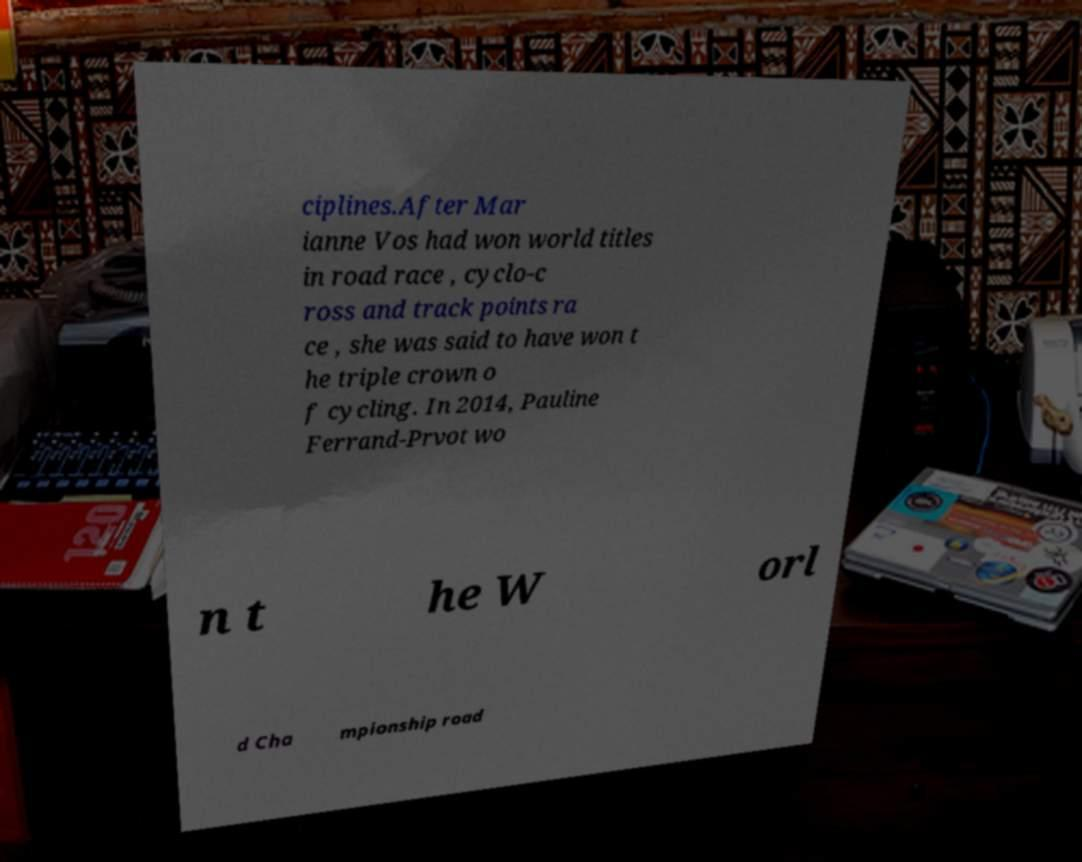Could you assist in decoding the text presented in this image and type it out clearly? ciplines.After Mar ianne Vos had won world titles in road race , cyclo-c ross and track points ra ce , she was said to have won t he triple crown o f cycling. In 2014, Pauline Ferrand-Prvot wo n t he W orl d Cha mpionship road 